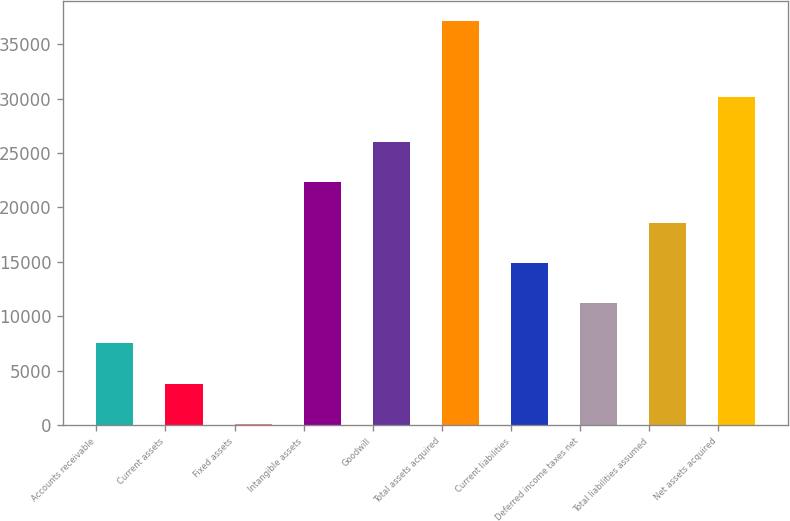Convert chart. <chart><loc_0><loc_0><loc_500><loc_500><bar_chart><fcel>Accounts receivable<fcel>Current assets<fcel>Fixed assets<fcel>Intangible assets<fcel>Goodwill<fcel>Total assets acquired<fcel>Current liabilities<fcel>Deferred income taxes net<fcel>Total liabilities assumed<fcel>Net assets acquired<nl><fcel>7501<fcel>3799.5<fcel>98<fcel>22307<fcel>26008.5<fcel>37113<fcel>14904<fcel>11202.5<fcel>18605.5<fcel>30141<nl></chart> 